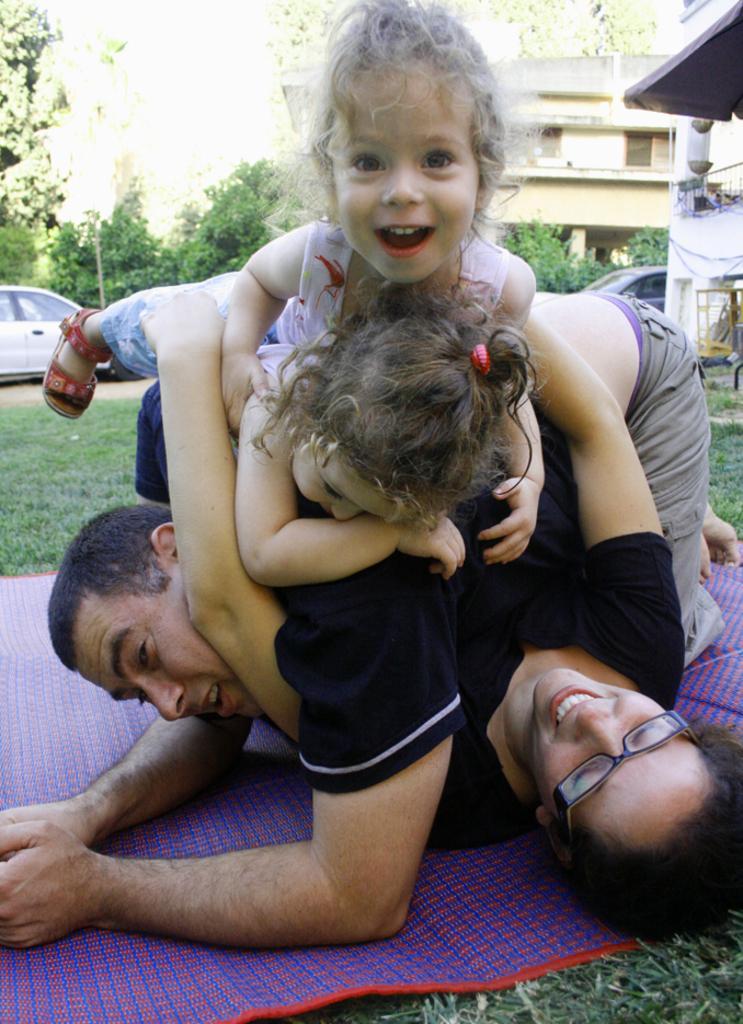Describe this image in one or two sentences. In this image, we can see people on the mat. There are buildings in the top right of the image. There is a car on the left side of the image. There are trees in the top left of the image. 